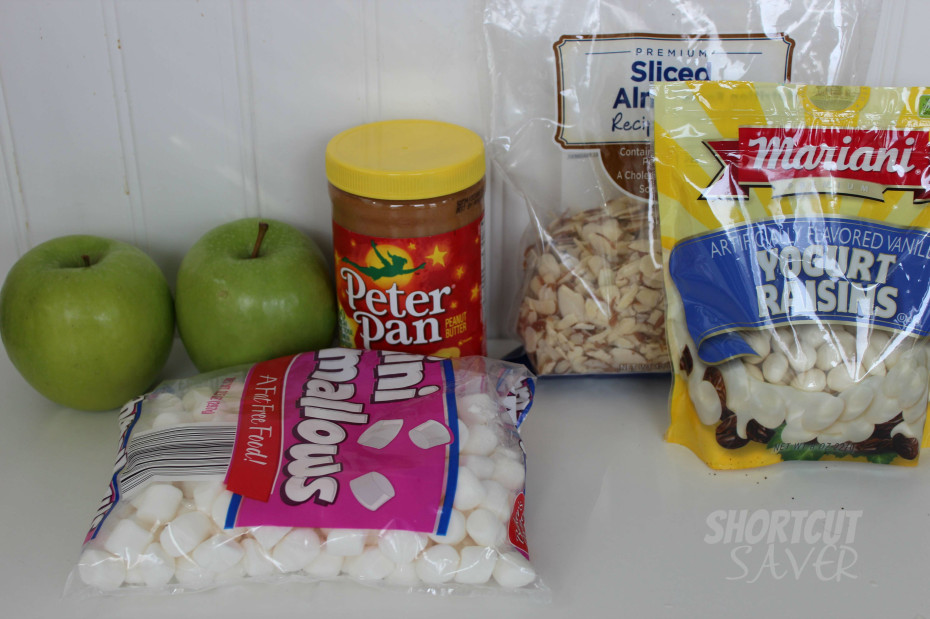What is the healthiest dish one can prepare with these items, considering nutrional balance? A nutritious dish featuring these ingredients would be an Apple-Almond Salad. Start by slicing the apples into thin wedges and mix in a bowl with yogurt-covered raisins and a handful of sliced almonds for crunch. Lightly drizzle some peanut butter mixed with a bit of water to thin it out over the salad as a dressing. This combination provides a good balance of fiber from the apples, protein and fat from the almonds, and a sweet touch from the raisins, making it a healthier but tasty option. 